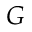Convert formula to latex. <formula><loc_0><loc_0><loc_500><loc_500>G</formula> 